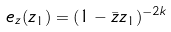Convert formula to latex. <formula><loc_0><loc_0><loc_500><loc_500>e _ { z } ( z _ { 1 } ) = ( 1 - \bar { z } z _ { 1 } ) ^ { - 2 k }</formula> 